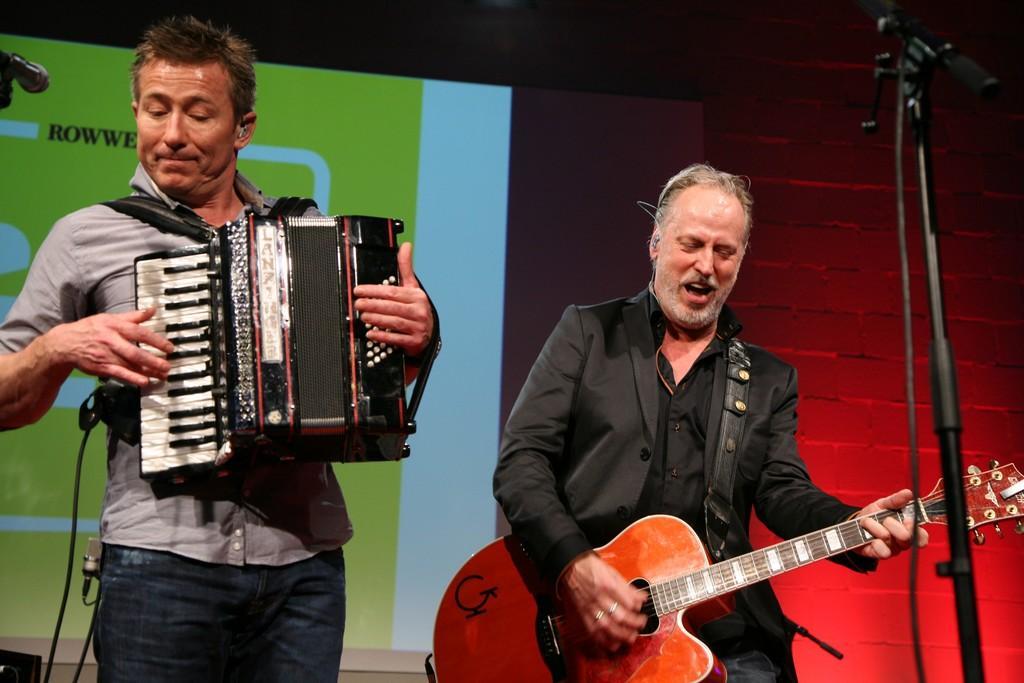Can you describe this image briefly? In a picture there are two men and at the right corner of the picture the person is wearing a black dress and playing a guitar and in the left corner of the picture the person is wearing a grey shirt and jeans and holding a musical instrument, behind them there is a big screen and in front of them there are microphones. 